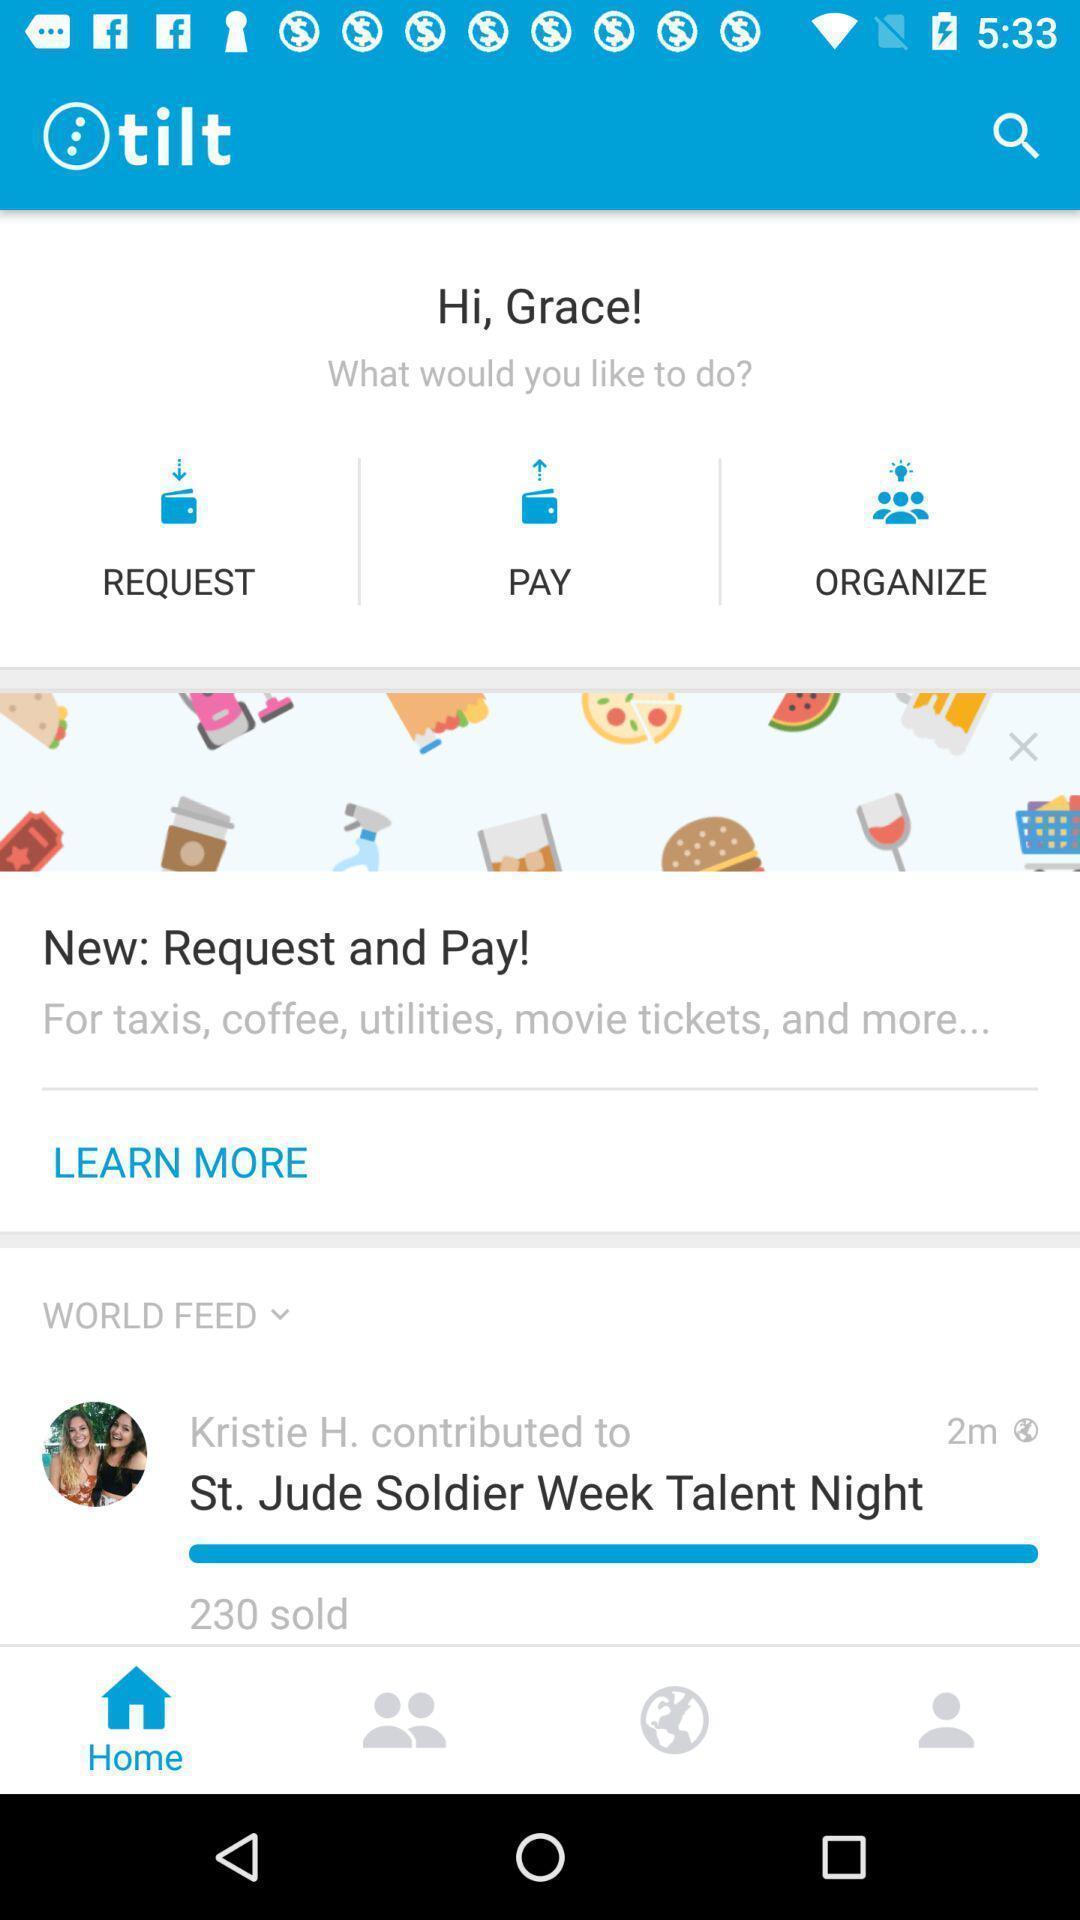Tell me what you see in this picture. Welcome page for profile and homepage. 